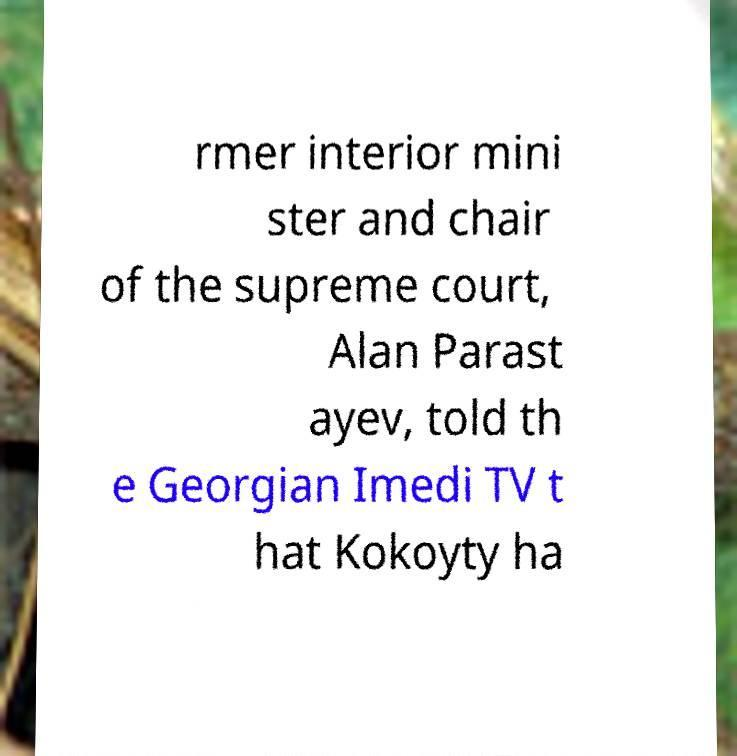There's text embedded in this image that I need extracted. Can you transcribe it verbatim? rmer interior mini ster and chair of the supreme court, Alan Parast ayev, told th e Georgian Imedi TV t hat Kokoyty ha 